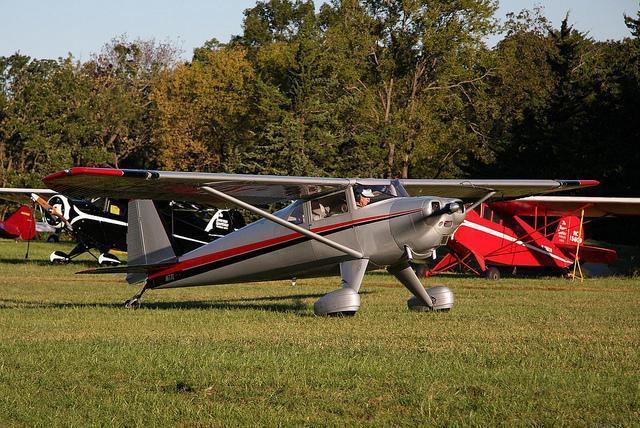How many planes have stripes?
Give a very brief answer. 3. How many airplanes are in the picture?
Give a very brief answer. 3. How many black dogs are in the image?
Give a very brief answer. 0. 